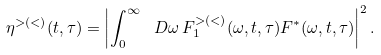<formula> <loc_0><loc_0><loc_500><loc_500>\eta ^ { > ( < ) } ( t , \tau ) = \left | \int _ { 0 } ^ { \infty } \ D \omega \, F ^ { > ( < ) } _ { 1 } ( \omega , t , \tau ) F ^ { * } ( \omega , t , \tau ) \right | ^ { 2 } .</formula> 